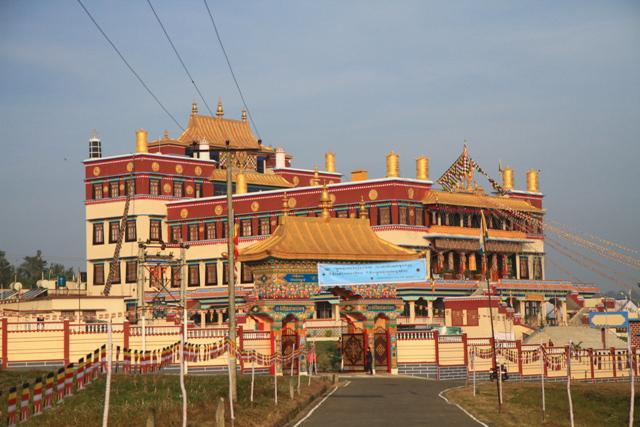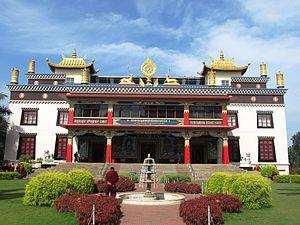The first image is the image on the left, the second image is the image on the right. Considering the images on both sides, is "There is an empty parking lot in front of a building in at least one of the images." valid? Answer yes or no. No. The first image is the image on the left, the second image is the image on the right. Analyze the images presented: Is the assertion "Left image includes a steep foliage-covered slope and a blue cloud-scattered sky in the scene with a building led to by a stairway." valid? Answer yes or no. No. 